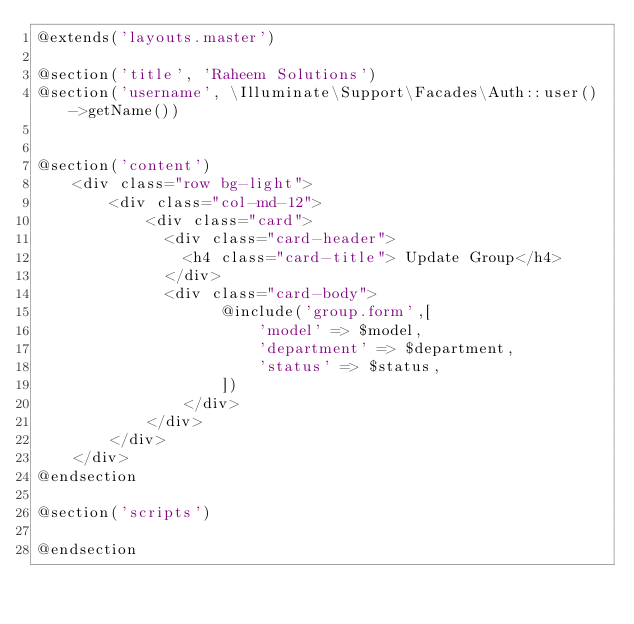Convert code to text. <code><loc_0><loc_0><loc_500><loc_500><_PHP_>@extends('layouts.master')

@section('title', 'Raheem Solutions')
@section('username', \Illuminate\Support\Facades\Auth::user()->getName())


@section('content')
    <div class="row bg-light">
        <div class="col-md-12">
            <div class="card">
              <div class="card-header">
                <h4 class="card-title"> Update Group</h4>
              </div>
              <div class="card-body">
                    @include('group.form',[
                        'model' => $model,
                        'department' => $department,
                        'status' => $status,
                    ])
                </div>
            </div>
        </div>
    </div>
@endsection

@section('scripts')
    
@endsection</code> 